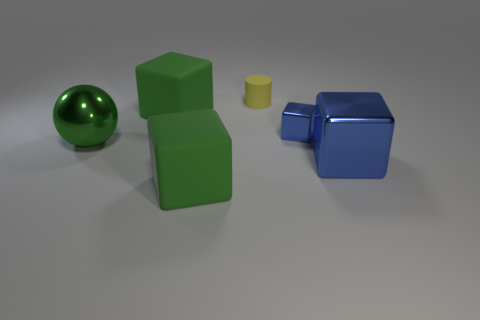Add 1 metallic objects. How many objects exist? 7 Subtract all cylinders. How many objects are left? 5 Subtract all small yellow shiny cylinders. Subtract all green shiny things. How many objects are left? 5 Add 3 large blue blocks. How many large blue blocks are left? 4 Add 4 small metal cubes. How many small metal cubes exist? 5 Subtract 0 purple cylinders. How many objects are left? 6 